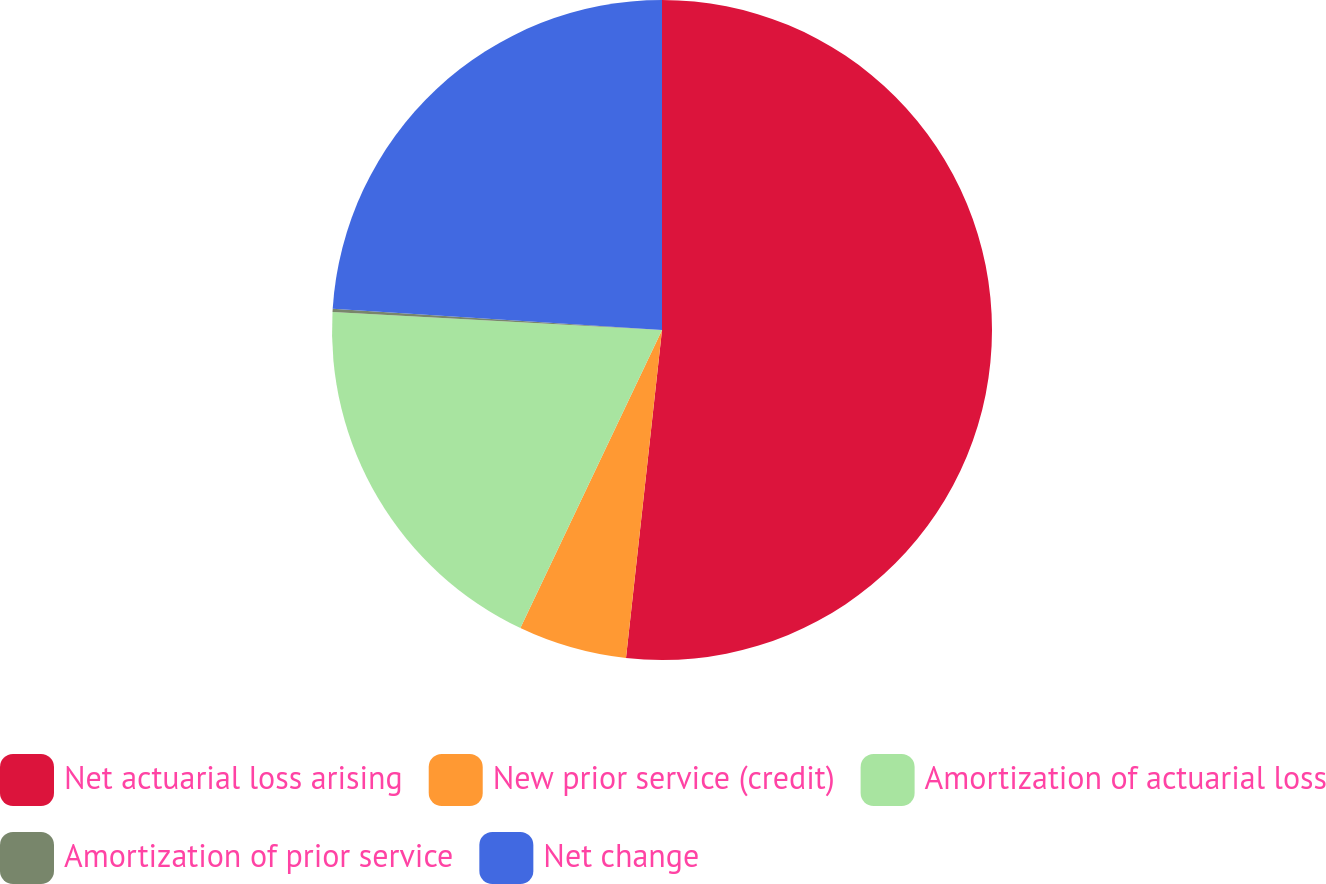Convert chart to OTSL. <chart><loc_0><loc_0><loc_500><loc_500><pie_chart><fcel>Net actuarial loss arising<fcel>New prior service (credit)<fcel>Amortization of actuarial loss<fcel>Amortization of prior service<fcel>Net change<nl><fcel>51.74%<fcel>5.32%<fcel>18.81%<fcel>0.16%<fcel>23.97%<nl></chart> 